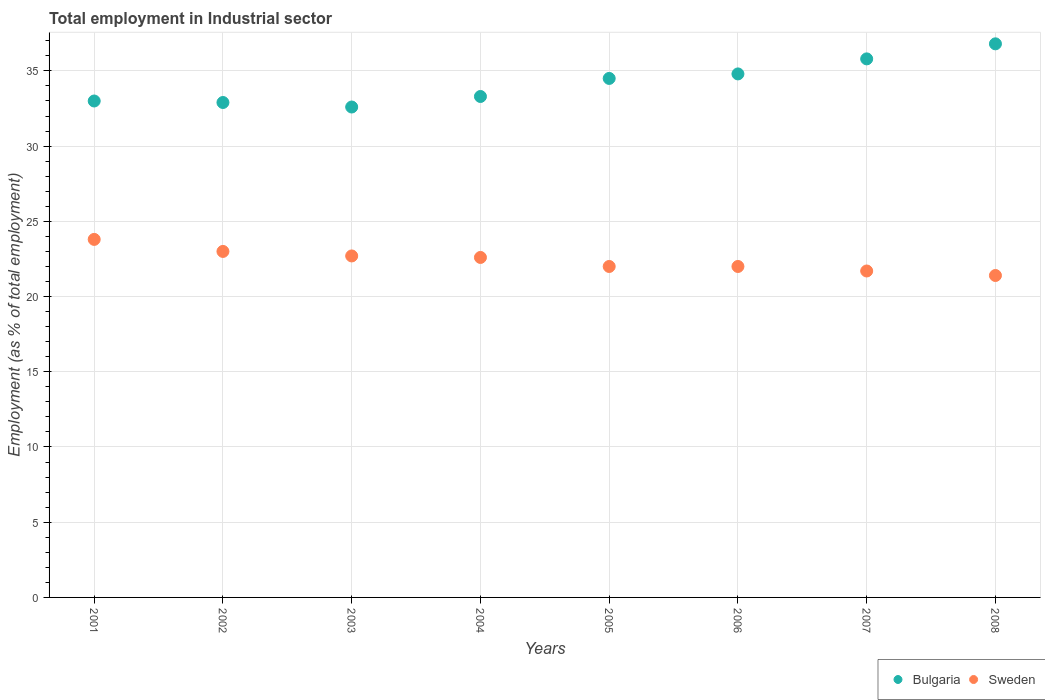How many different coloured dotlines are there?
Offer a very short reply. 2. What is the employment in industrial sector in Sweden in 2003?
Offer a very short reply. 22.7. Across all years, what is the maximum employment in industrial sector in Bulgaria?
Your answer should be very brief. 36.8. Across all years, what is the minimum employment in industrial sector in Bulgaria?
Your response must be concise. 32.6. In which year was the employment in industrial sector in Bulgaria maximum?
Offer a very short reply. 2008. What is the total employment in industrial sector in Bulgaria in the graph?
Offer a terse response. 273.7. What is the difference between the employment in industrial sector in Bulgaria in 2002 and that in 2008?
Ensure brevity in your answer.  -3.9. What is the difference between the employment in industrial sector in Bulgaria in 2003 and the employment in industrial sector in Sweden in 2008?
Your answer should be very brief. 11.2. What is the average employment in industrial sector in Bulgaria per year?
Make the answer very short. 34.21. In the year 2001, what is the difference between the employment in industrial sector in Bulgaria and employment in industrial sector in Sweden?
Offer a terse response. 9.2. What is the ratio of the employment in industrial sector in Sweden in 2001 to that in 2003?
Keep it short and to the point. 1.05. Is the difference between the employment in industrial sector in Bulgaria in 2005 and 2006 greater than the difference between the employment in industrial sector in Sweden in 2005 and 2006?
Provide a succinct answer. No. What is the difference between the highest and the second highest employment in industrial sector in Sweden?
Give a very brief answer. 0.8. What is the difference between the highest and the lowest employment in industrial sector in Sweden?
Offer a terse response. 2.4. In how many years, is the employment in industrial sector in Bulgaria greater than the average employment in industrial sector in Bulgaria taken over all years?
Ensure brevity in your answer.  4. Is the sum of the employment in industrial sector in Bulgaria in 2003 and 2006 greater than the maximum employment in industrial sector in Sweden across all years?
Give a very brief answer. Yes. Does the employment in industrial sector in Sweden monotonically increase over the years?
Offer a very short reply. No. What is the difference between two consecutive major ticks on the Y-axis?
Your answer should be very brief. 5. Are the values on the major ticks of Y-axis written in scientific E-notation?
Your answer should be very brief. No. Where does the legend appear in the graph?
Ensure brevity in your answer.  Bottom right. How many legend labels are there?
Make the answer very short. 2. How are the legend labels stacked?
Offer a very short reply. Horizontal. What is the title of the graph?
Keep it short and to the point. Total employment in Industrial sector. What is the label or title of the Y-axis?
Offer a terse response. Employment (as % of total employment). What is the Employment (as % of total employment) of Bulgaria in 2001?
Your answer should be very brief. 33. What is the Employment (as % of total employment) of Sweden in 2001?
Your response must be concise. 23.8. What is the Employment (as % of total employment) in Bulgaria in 2002?
Offer a very short reply. 32.9. What is the Employment (as % of total employment) in Bulgaria in 2003?
Keep it short and to the point. 32.6. What is the Employment (as % of total employment) in Sweden in 2003?
Ensure brevity in your answer.  22.7. What is the Employment (as % of total employment) in Bulgaria in 2004?
Ensure brevity in your answer.  33.3. What is the Employment (as % of total employment) of Sweden in 2004?
Provide a short and direct response. 22.6. What is the Employment (as % of total employment) in Bulgaria in 2005?
Provide a short and direct response. 34.5. What is the Employment (as % of total employment) in Sweden in 2005?
Provide a succinct answer. 22. What is the Employment (as % of total employment) in Bulgaria in 2006?
Provide a succinct answer. 34.8. What is the Employment (as % of total employment) of Sweden in 2006?
Your answer should be very brief. 22. What is the Employment (as % of total employment) of Bulgaria in 2007?
Your answer should be compact. 35.8. What is the Employment (as % of total employment) of Sweden in 2007?
Your answer should be very brief. 21.7. What is the Employment (as % of total employment) of Bulgaria in 2008?
Provide a succinct answer. 36.8. What is the Employment (as % of total employment) of Sweden in 2008?
Offer a very short reply. 21.4. Across all years, what is the maximum Employment (as % of total employment) in Bulgaria?
Your answer should be very brief. 36.8. Across all years, what is the maximum Employment (as % of total employment) of Sweden?
Ensure brevity in your answer.  23.8. Across all years, what is the minimum Employment (as % of total employment) of Bulgaria?
Keep it short and to the point. 32.6. Across all years, what is the minimum Employment (as % of total employment) in Sweden?
Offer a very short reply. 21.4. What is the total Employment (as % of total employment) of Bulgaria in the graph?
Ensure brevity in your answer.  273.7. What is the total Employment (as % of total employment) of Sweden in the graph?
Provide a short and direct response. 179.2. What is the difference between the Employment (as % of total employment) in Sweden in 2001 and that in 2002?
Your response must be concise. 0.8. What is the difference between the Employment (as % of total employment) of Bulgaria in 2001 and that in 2003?
Offer a very short reply. 0.4. What is the difference between the Employment (as % of total employment) in Sweden in 2001 and that in 2005?
Offer a very short reply. 1.8. What is the difference between the Employment (as % of total employment) of Bulgaria in 2001 and that in 2006?
Your answer should be compact. -1.8. What is the difference between the Employment (as % of total employment) of Sweden in 2001 and that in 2006?
Give a very brief answer. 1.8. What is the difference between the Employment (as % of total employment) in Sweden in 2001 and that in 2007?
Give a very brief answer. 2.1. What is the difference between the Employment (as % of total employment) of Sweden in 2002 and that in 2004?
Provide a short and direct response. 0.4. What is the difference between the Employment (as % of total employment) in Sweden in 2002 and that in 2005?
Your response must be concise. 1. What is the difference between the Employment (as % of total employment) in Bulgaria in 2002 and that in 2006?
Provide a succinct answer. -1.9. What is the difference between the Employment (as % of total employment) in Sweden in 2002 and that in 2006?
Provide a short and direct response. 1. What is the difference between the Employment (as % of total employment) of Sweden in 2002 and that in 2007?
Offer a very short reply. 1.3. What is the difference between the Employment (as % of total employment) of Bulgaria in 2002 and that in 2008?
Your answer should be compact. -3.9. What is the difference between the Employment (as % of total employment) of Sweden in 2003 and that in 2005?
Offer a terse response. 0.7. What is the difference between the Employment (as % of total employment) of Bulgaria in 2003 and that in 2007?
Provide a short and direct response. -3.2. What is the difference between the Employment (as % of total employment) of Bulgaria in 2003 and that in 2008?
Your answer should be compact. -4.2. What is the difference between the Employment (as % of total employment) in Bulgaria in 2004 and that in 2005?
Your answer should be compact. -1.2. What is the difference between the Employment (as % of total employment) of Sweden in 2004 and that in 2005?
Provide a short and direct response. 0.6. What is the difference between the Employment (as % of total employment) in Bulgaria in 2004 and that in 2007?
Give a very brief answer. -2.5. What is the difference between the Employment (as % of total employment) of Bulgaria in 2004 and that in 2008?
Make the answer very short. -3.5. What is the difference between the Employment (as % of total employment) of Sweden in 2004 and that in 2008?
Ensure brevity in your answer.  1.2. What is the difference between the Employment (as % of total employment) of Bulgaria in 2005 and that in 2006?
Your answer should be compact. -0.3. What is the difference between the Employment (as % of total employment) in Bulgaria in 2005 and that in 2007?
Your answer should be compact. -1.3. What is the difference between the Employment (as % of total employment) in Sweden in 2005 and that in 2007?
Offer a terse response. 0.3. What is the difference between the Employment (as % of total employment) in Bulgaria in 2006 and that in 2007?
Make the answer very short. -1. What is the difference between the Employment (as % of total employment) in Sweden in 2006 and that in 2007?
Your answer should be very brief. 0.3. What is the difference between the Employment (as % of total employment) in Bulgaria in 2006 and that in 2008?
Provide a succinct answer. -2. What is the difference between the Employment (as % of total employment) of Sweden in 2006 and that in 2008?
Provide a short and direct response. 0.6. What is the difference between the Employment (as % of total employment) of Bulgaria in 2007 and that in 2008?
Give a very brief answer. -1. What is the difference between the Employment (as % of total employment) in Sweden in 2007 and that in 2008?
Provide a short and direct response. 0.3. What is the difference between the Employment (as % of total employment) in Bulgaria in 2001 and the Employment (as % of total employment) in Sweden in 2002?
Give a very brief answer. 10. What is the difference between the Employment (as % of total employment) in Bulgaria in 2001 and the Employment (as % of total employment) in Sweden in 2003?
Your response must be concise. 10.3. What is the difference between the Employment (as % of total employment) in Bulgaria in 2001 and the Employment (as % of total employment) in Sweden in 2004?
Keep it short and to the point. 10.4. What is the difference between the Employment (as % of total employment) in Bulgaria in 2001 and the Employment (as % of total employment) in Sweden in 2005?
Give a very brief answer. 11. What is the difference between the Employment (as % of total employment) in Bulgaria in 2001 and the Employment (as % of total employment) in Sweden in 2008?
Your response must be concise. 11.6. What is the difference between the Employment (as % of total employment) of Bulgaria in 2002 and the Employment (as % of total employment) of Sweden in 2003?
Offer a terse response. 10.2. What is the difference between the Employment (as % of total employment) of Bulgaria in 2002 and the Employment (as % of total employment) of Sweden in 2006?
Ensure brevity in your answer.  10.9. What is the difference between the Employment (as % of total employment) in Bulgaria in 2003 and the Employment (as % of total employment) in Sweden in 2006?
Keep it short and to the point. 10.6. What is the difference between the Employment (as % of total employment) in Bulgaria in 2003 and the Employment (as % of total employment) in Sweden in 2007?
Make the answer very short. 10.9. What is the difference between the Employment (as % of total employment) of Bulgaria in 2004 and the Employment (as % of total employment) of Sweden in 2005?
Give a very brief answer. 11.3. What is the difference between the Employment (as % of total employment) of Bulgaria in 2004 and the Employment (as % of total employment) of Sweden in 2006?
Ensure brevity in your answer.  11.3. What is the difference between the Employment (as % of total employment) in Bulgaria in 2004 and the Employment (as % of total employment) in Sweden in 2007?
Keep it short and to the point. 11.6. What is the difference between the Employment (as % of total employment) in Bulgaria in 2004 and the Employment (as % of total employment) in Sweden in 2008?
Provide a short and direct response. 11.9. What is the difference between the Employment (as % of total employment) of Bulgaria in 2005 and the Employment (as % of total employment) of Sweden in 2006?
Make the answer very short. 12.5. What is the average Employment (as % of total employment) in Bulgaria per year?
Keep it short and to the point. 34.21. What is the average Employment (as % of total employment) of Sweden per year?
Offer a terse response. 22.4. In the year 2004, what is the difference between the Employment (as % of total employment) in Bulgaria and Employment (as % of total employment) in Sweden?
Your response must be concise. 10.7. In the year 2005, what is the difference between the Employment (as % of total employment) in Bulgaria and Employment (as % of total employment) in Sweden?
Ensure brevity in your answer.  12.5. What is the ratio of the Employment (as % of total employment) in Sweden in 2001 to that in 2002?
Your answer should be compact. 1.03. What is the ratio of the Employment (as % of total employment) of Bulgaria in 2001 to that in 2003?
Ensure brevity in your answer.  1.01. What is the ratio of the Employment (as % of total employment) of Sweden in 2001 to that in 2003?
Give a very brief answer. 1.05. What is the ratio of the Employment (as % of total employment) of Sweden in 2001 to that in 2004?
Ensure brevity in your answer.  1.05. What is the ratio of the Employment (as % of total employment) in Bulgaria in 2001 to that in 2005?
Your answer should be compact. 0.96. What is the ratio of the Employment (as % of total employment) of Sweden in 2001 to that in 2005?
Provide a succinct answer. 1.08. What is the ratio of the Employment (as % of total employment) of Bulgaria in 2001 to that in 2006?
Provide a succinct answer. 0.95. What is the ratio of the Employment (as % of total employment) in Sweden in 2001 to that in 2006?
Provide a succinct answer. 1.08. What is the ratio of the Employment (as % of total employment) of Bulgaria in 2001 to that in 2007?
Your answer should be very brief. 0.92. What is the ratio of the Employment (as % of total employment) in Sweden in 2001 to that in 2007?
Offer a very short reply. 1.1. What is the ratio of the Employment (as % of total employment) in Bulgaria in 2001 to that in 2008?
Your response must be concise. 0.9. What is the ratio of the Employment (as % of total employment) in Sweden in 2001 to that in 2008?
Give a very brief answer. 1.11. What is the ratio of the Employment (as % of total employment) in Bulgaria in 2002 to that in 2003?
Give a very brief answer. 1.01. What is the ratio of the Employment (as % of total employment) in Sweden in 2002 to that in 2003?
Make the answer very short. 1.01. What is the ratio of the Employment (as % of total employment) in Sweden in 2002 to that in 2004?
Provide a short and direct response. 1.02. What is the ratio of the Employment (as % of total employment) of Bulgaria in 2002 to that in 2005?
Make the answer very short. 0.95. What is the ratio of the Employment (as % of total employment) of Sweden in 2002 to that in 2005?
Provide a succinct answer. 1.05. What is the ratio of the Employment (as % of total employment) of Bulgaria in 2002 to that in 2006?
Your response must be concise. 0.95. What is the ratio of the Employment (as % of total employment) of Sweden in 2002 to that in 2006?
Make the answer very short. 1.05. What is the ratio of the Employment (as % of total employment) in Bulgaria in 2002 to that in 2007?
Provide a short and direct response. 0.92. What is the ratio of the Employment (as % of total employment) of Sweden in 2002 to that in 2007?
Keep it short and to the point. 1.06. What is the ratio of the Employment (as % of total employment) of Bulgaria in 2002 to that in 2008?
Provide a succinct answer. 0.89. What is the ratio of the Employment (as % of total employment) in Sweden in 2002 to that in 2008?
Ensure brevity in your answer.  1.07. What is the ratio of the Employment (as % of total employment) of Bulgaria in 2003 to that in 2004?
Ensure brevity in your answer.  0.98. What is the ratio of the Employment (as % of total employment) of Sweden in 2003 to that in 2004?
Your answer should be compact. 1. What is the ratio of the Employment (as % of total employment) of Bulgaria in 2003 to that in 2005?
Your answer should be compact. 0.94. What is the ratio of the Employment (as % of total employment) in Sweden in 2003 to that in 2005?
Ensure brevity in your answer.  1.03. What is the ratio of the Employment (as % of total employment) of Bulgaria in 2003 to that in 2006?
Your answer should be very brief. 0.94. What is the ratio of the Employment (as % of total employment) of Sweden in 2003 to that in 2006?
Your answer should be very brief. 1.03. What is the ratio of the Employment (as % of total employment) of Bulgaria in 2003 to that in 2007?
Your answer should be very brief. 0.91. What is the ratio of the Employment (as % of total employment) of Sweden in 2003 to that in 2007?
Make the answer very short. 1.05. What is the ratio of the Employment (as % of total employment) of Bulgaria in 2003 to that in 2008?
Your response must be concise. 0.89. What is the ratio of the Employment (as % of total employment) in Sweden in 2003 to that in 2008?
Your answer should be very brief. 1.06. What is the ratio of the Employment (as % of total employment) of Bulgaria in 2004 to that in 2005?
Ensure brevity in your answer.  0.97. What is the ratio of the Employment (as % of total employment) in Sweden in 2004 to that in 2005?
Offer a very short reply. 1.03. What is the ratio of the Employment (as % of total employment) of Bulgaria in 2004 to that in 2006?
Ensure brevity in your answer.  0.96. What is the ratio of the Employment (as % of total employment) in Sweden in 2004 to that in 2006?
Give a very brief answer. 1.03. What is the ratio of the Employment (as % of total employment) of Bulgaria in 2004 to that in 2007?
Make the answer very short. 0.93. What is the ratio of the Employment (as % of total employment) of Sweden in 2004 to that in 2007?
Offer a very short reply. 1.04. What is the ratio of the Employment (as % of total employment) of Bulgaria in 2004 to that in 2008?
Offer a very short reply. 0.9. What is the ratio of the Employment (as % of total employment) of Sweden in 2004 to that in 2008?
Give a very brief answer. 1.06. What is the ratio of the Employment (as % of total employment) of Sweden in 2005 to that in 2006?
Your answer should be compact. 1. What is the ratio of the Employment (as % of total employment) in Bulgaria in 2005 to that in 2007?
Your response must be concise. 0.96. What is the ratio of the Employment (as % of total employment) in Sweden in 2005 to that in 2007?
Your answer should be very brief. 1.01. What is the ratio of the Employment (as % of total employment) of Bulgaria in 2005 to that in 2008?
Make the answer very short. 0.94. What is the ratio of the Employment (as % of total employment) in Sweden in 2005 to that in 2008?
Offer a very short reply. 1.03. What is the ratio of the Employment (as % of total employment) in Bulgaria in 2006 to that in 2007?
Keep it short and to the point. 0.97. What is the ratio of the Employment (as % of total employment) in Sweden in 2006 to that in 2007?
Your answer should be compact. 1.01. What is the ratio of the Employment (as % of total employment) of Bulgaria in 2006 to that in 2008?
Make the answer very short. 0.95. What is the ratio of the Employment (as % of total employment) of Sweden in 2006 to that in 2008?
Your answer should be compact. 1.03. What is the ratio of the Employment (as % of total employment) of Bulgaria in 2007 to that in 2008?
Your answer should be compact. 0.97. What is the difference between the highest and the lowest Employment (as % of total employment) in Bulgaria?
Give a very brief answer. 4.2. What is the difference between the highest and the lowest Employment (as % of total employment) of Sweden?
Offer a terse response. 2.4. 